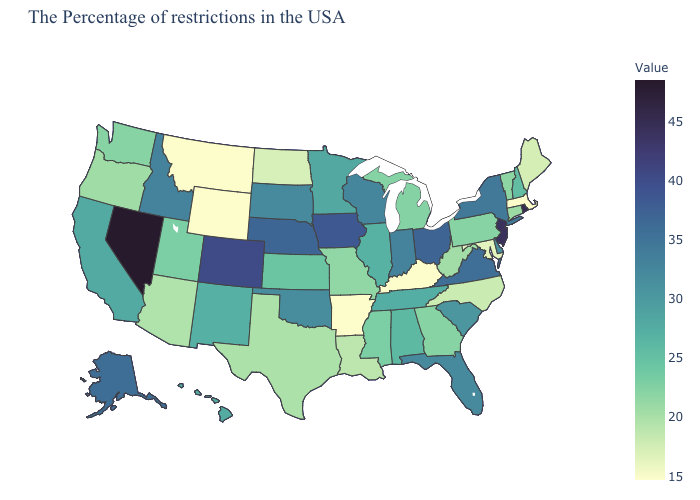Does Louisiana have a higher value than Delaware?
Concise answer only. No. Among the states that border South Carolina , does North Carolina have the lowest value?
Concise answer only. Yes. Does Nevada have the highest value in the West?
Be succinct. Yes. Among the states that border Pennsylvania , does West Virginia have the lowest value?
Write a very short answer. No. Does Alaska have a higher value than Rhode Island?
Short answer required. No. Does the map have missing data?
Short answer required. No. Does Nevada have the highest value in the USA?
Give a very brief answer. Yes. 